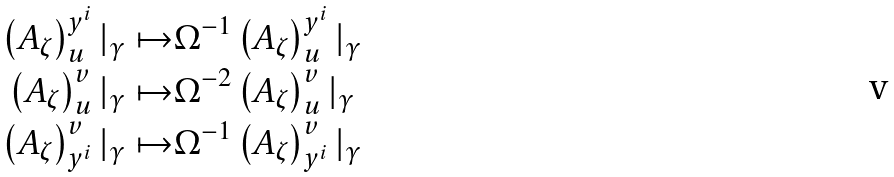<formula> <loc_0><loc_0><loc_500><loc_500>\left ( A _ { \zeta } \right ) ^ { y ^ { i } } _ { u } | _ { \gamma } \mapsto & \Omega ^ { - 1 } \left ( A _ { \zeta } \right ) ^ { y ^ { i } } _ { u } | _ { \gamma } \\ \left ( A _ { \zeta } \right ) ^ { v } _ { u } | _ { \gamma } \mapsto & \Omega ^ { - 2 } \left ( A _ { \zeta } \right ) ^ { v } _ { u } | _ { \gamma } \\ \left ( A _ { \zeta } \right ) ^ { v } _ { y ^ { i } } | _ { \gamma } \mapsto & \Omega ^ { - 1 } \left ( A _ { \zeta } \right ) ^ { v } _ { y ^ { i } } | _ { \gamma }</formula> 